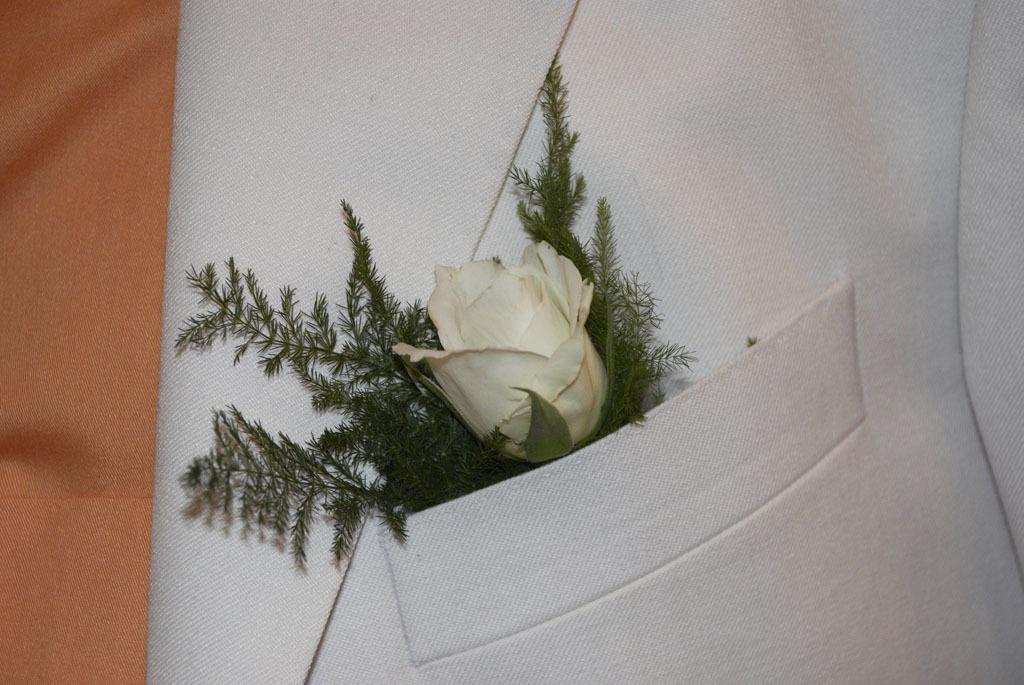What is the main focus of the image? The main focus of the image is the pocket of a shirt. What is inside the pocket? The pocket contains leaves and a flower. Can you describe the object on the left side of the image? There is an orange color object on the left side of the image. How many boats can be seen in the image? There are no boats present in the image. What type of industry is depicted in the image? There is no industry depicted in the image. 